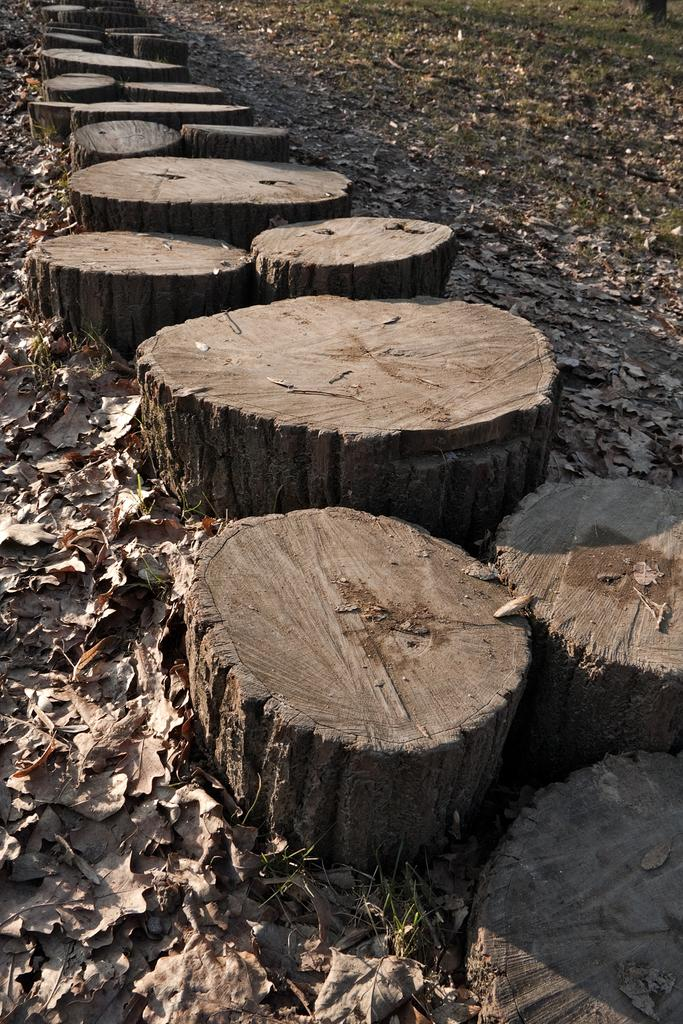What type of material are the objects in the image made of? The objects in the image are made of wood. What can be seen on the ground in the image? There are dried leaves on the ground in the image. Can you tell me how many snakes are slithering around the wooden objects in the image? There are no snakes present in the image. What type of arm is visible in the image? There is no arm visible in the image. 